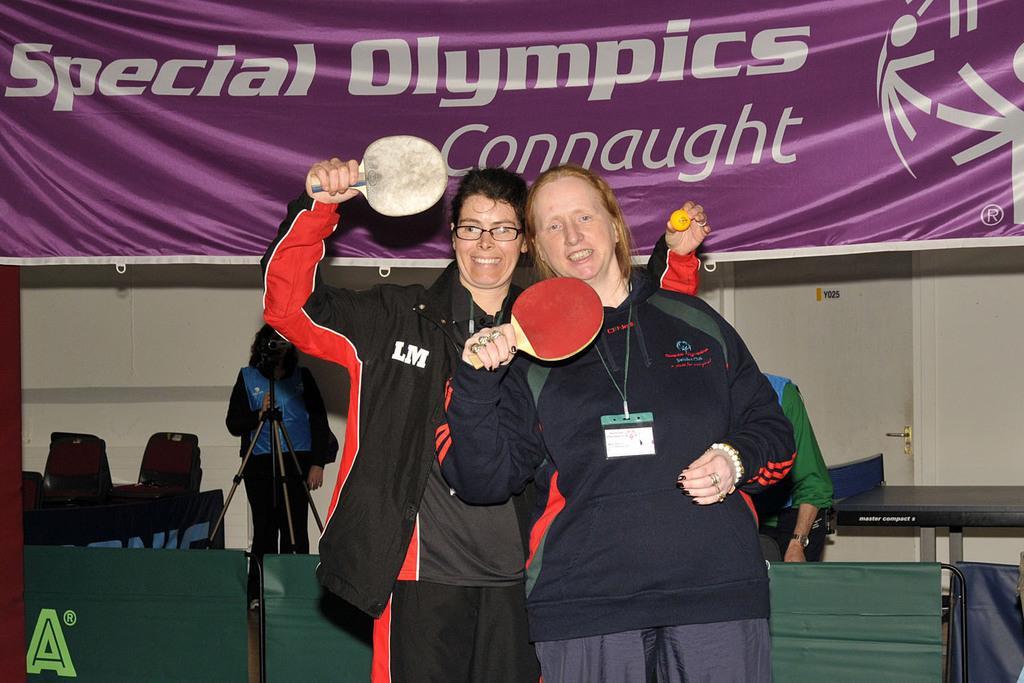Please provide a concise description of this image. In this picture there are two women who are holding tennis bats and ball in their hands. There is another woman holding a camera. There us tennis table and a banner at the background. 